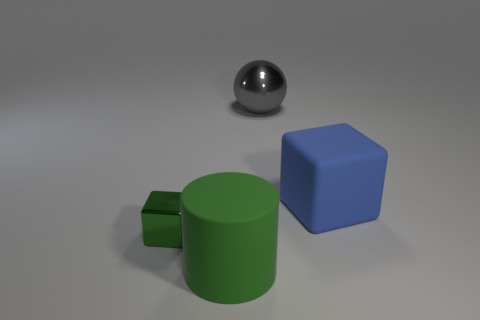Add 2 gray metal things. How many objects exist? 6 Subtract all blue blocks. How many blocks are left? 1 Subtract 1 cylinders. How many cylinders are left? 0 Subtract 1 gray spheres. How many objects are left? 3 Subtract all cylinders. How many objects are left? 3 Subtract all brown blocks. Subtract all blue cylinders. How many blocks are left? 2 Subtract all cyan cylinders. How many green cubes are left? 1 Subtract all big blue rubber spheres. Subtract all big cubes. How many objects are left? 3 Add 2 green shiny objects. How many green shiny objects are left? 3 Add 4 large spheres. How many large spheres exist? 5 